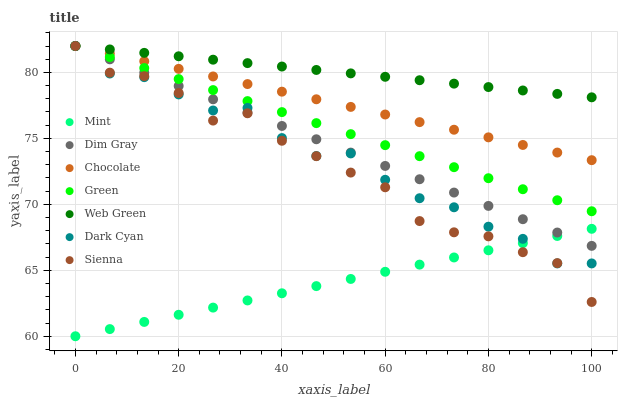Does Mint have the minimum area under the curve?
Answer yes or no. Yes. Does Web Green have the maximum area under the curve?
Answer yes or no. Yes. Does Chocolate have the minimum area under the curve?
Answer yes or no. No. Does Chocolate have the maximum area under the curve?
Answer yes or no. No. Is Mint the smoothest?
Answer yes or no. Yes. Is Sienna the roughest?
Answer yes or no. Yes. Is Web Green the smoothest?
Answer yes or no. No. Is Web Green the roughest?
Answer yes or no. No. Does Mint have the lowest value?
Answer yes or no. Yes. Does Chocolate have the lowest value?
Answer yes or no. No. Does Dark Cyan have the highest value?
Answer yes or no. Yes. Does Mint have the highest value?
Answer yes or no. No. Is Mint less than Chocolate?
Answer yes or no. Yes. Is Web Green greater than Mint?
Answer yes or no. Yes. Does Mint intersect Dim Gray?
Answer yes or no. Yes. Is Mint less than Dim Gray?
Answer yes or no. No. Is Mint greater than Dim Gray?
Answer yes or no. No. Does Mint intersect Chocolate?
Answer yes or no. No. 